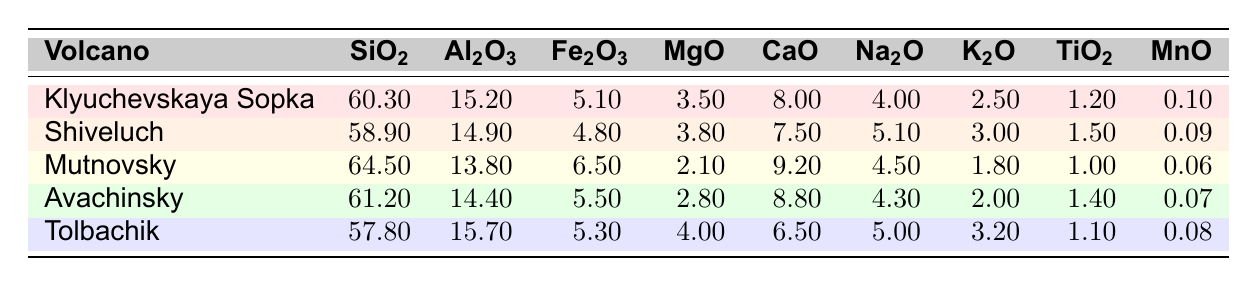What is the SiO2 percentage in Klyuchevskaya Sopka? Klyuchevskaya Sopka has a SiO2 percentage listed in the table, which can be found in the relevant column for that volcano. The value is 60.3.
Answer: 60.3 Which volcano has the highest Al2O3 content? To find the highest Al2O3 content, we compare the values in the Al2O3 column across all the volcanoes. The highest value is 15.7 for Tolbachik.
Answer: Tolbachik What is the average Fe2O3 content of all listed volcanoes? The Fe2O3 values for the five volcanoes are: 5.1, 4.8, 6.5, 5.5, and 5.3. First, sum these values: 5.1 + 4.8 + 6.5 + 5.5 + 5.3 = 27.2. There are 5 volcanoes, so the average is 27.2/5 = 5.44.
Answer: 5.44 Is the MgO content of Mutnovsky greater than that of Klyuchevskaya Sopka? Comparing the MgO values of both volcanoes, Mutnovsky has 2.1 and Klyuchevskaya Sopka has 3.5. Since 2.1 is not greater than 3.5, the answer is no.
Answer: No What is the difference in K2O content between Shiveluch and Avachinsky? Shiveluch has a K2O value of 3.0, and Avachinsky has a K2O value of 2.0. To find the difference, subtract the K2O value of Avachinsky from that of Shiveluch: 3.0 - 2.0 = 1.0.
Answer: 1.0 How does the MgO content of Tolbachik compare to that of Mutnovsky? Tolbachik has an MgO content of 4.0, while Mutnovsky has a MgO content of 2.1. Comparing these, 4.0 is greater than 2.1, indicating Tolbachik has a higher MgO content.
Answer: Tolbachik has higher MgO content Which volcano has the lowest SiO2? By examining the SiO2 values, we see that Tolbachik has the lowest value of 57.8 compared to the others.
Answer: Tolbachik Is the CaO content of Mutnovsky higher than that of Avachinsky? Checking the calcium oxide values, Mutnovsky has 9.2 and Avachinsky has 8.8. Since 9.2 is greater than 8.8, the answer is yes.
Answer: Yes What is the total summation of Na2O content across all volcanoes? The Na2O values are: 4.0, 5.1, 4.5, 4.3, and 5.0. Adding these values gives: 4.0 + 5.1 + 4.5 + 4.3 + 5.0 = 23.0.
Answer: 23.0 